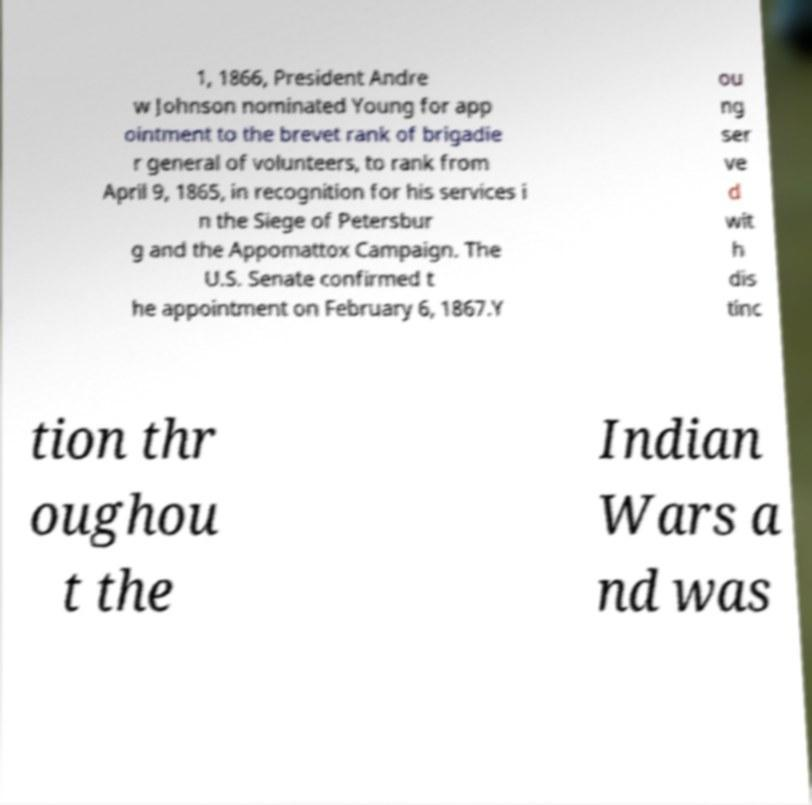Could you extract and type out the text from this image? 1, 1866, President Andre w Johnson nominated Young for app ointment to the brevet rank of brigadie r general of volunteers, to rank from April 9, 1865, in recognition for his services i n the Siege of Petersbur g and the Appomattox Campaign. The U.S. Senate confirmed t he appointment on February 6, 1867.Y ou ng ser ve d wit h dis tinc tion thr oughou t the Indian Wars a nd was 